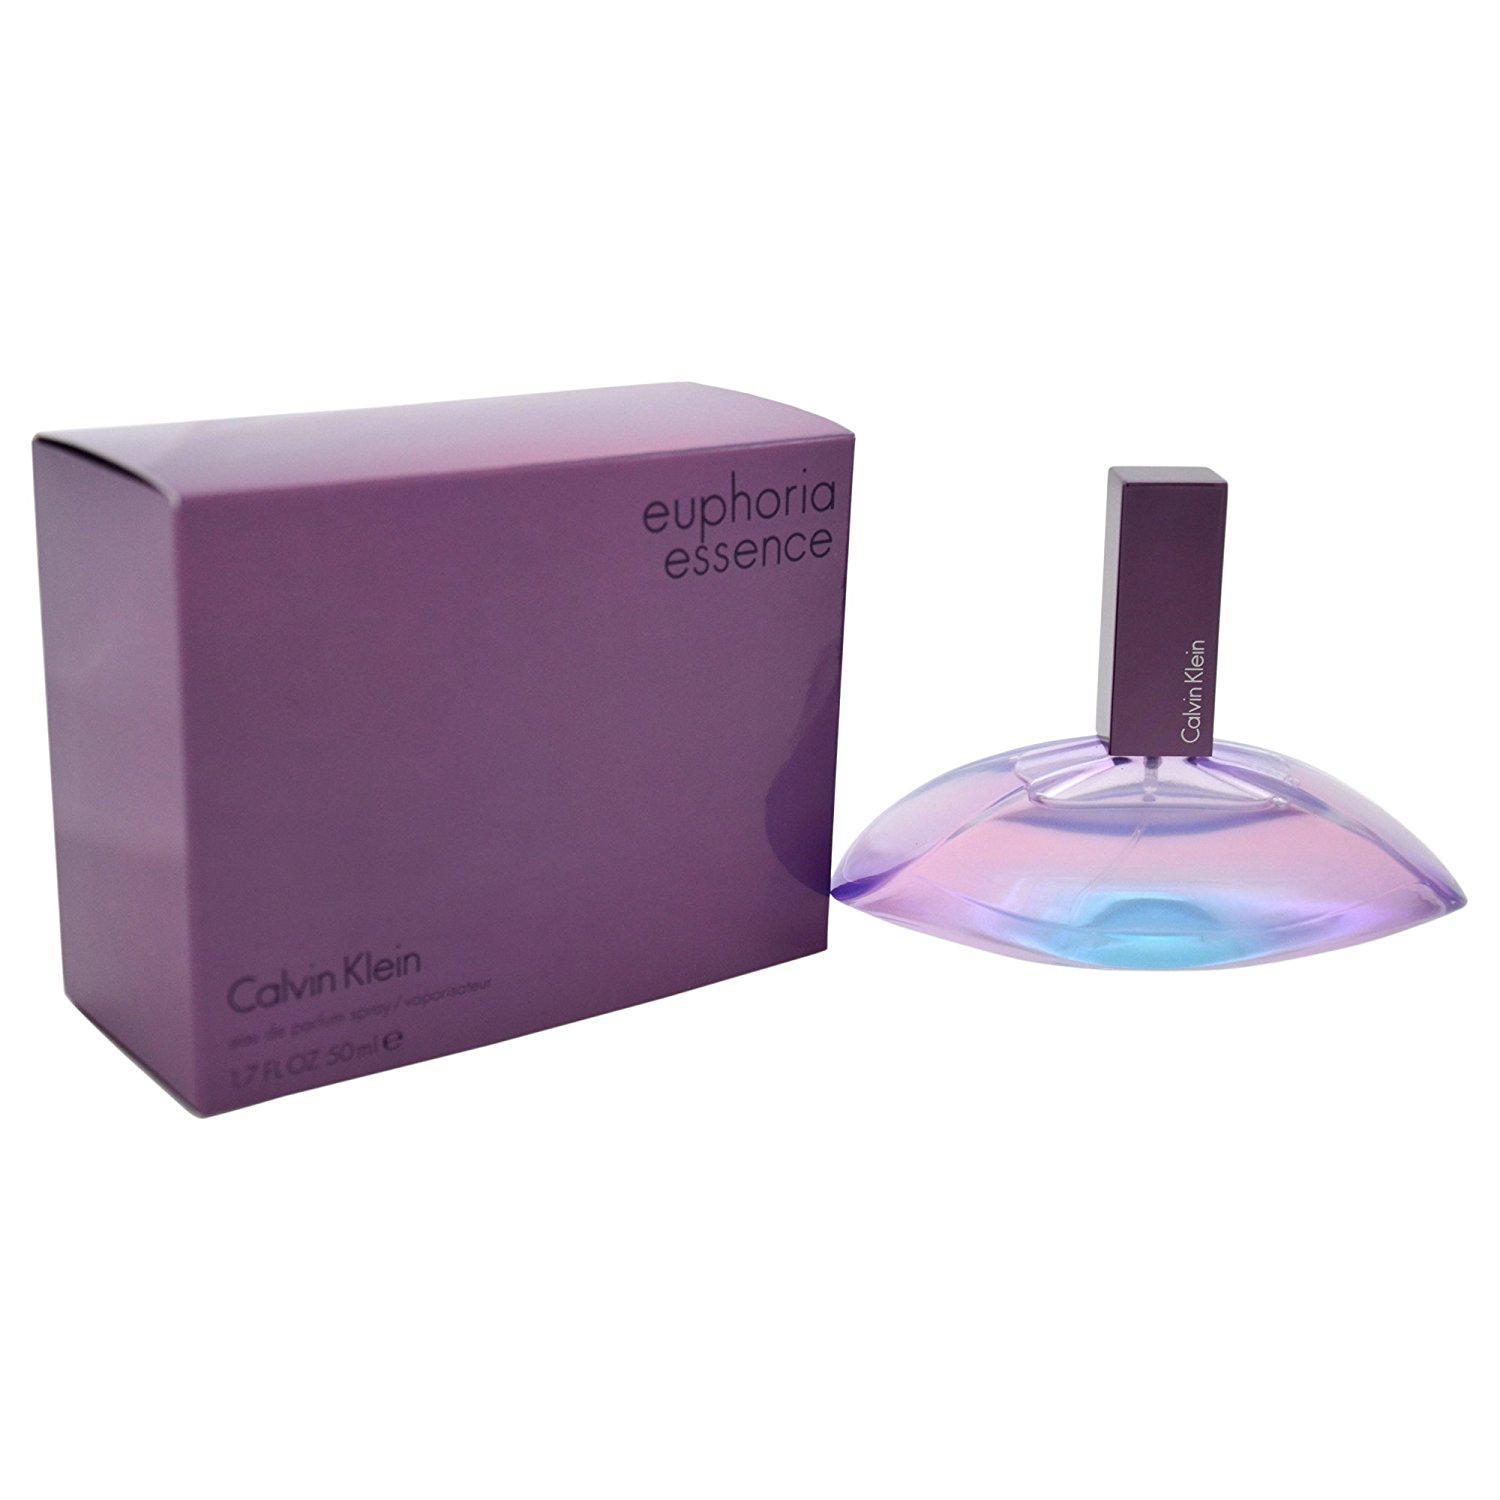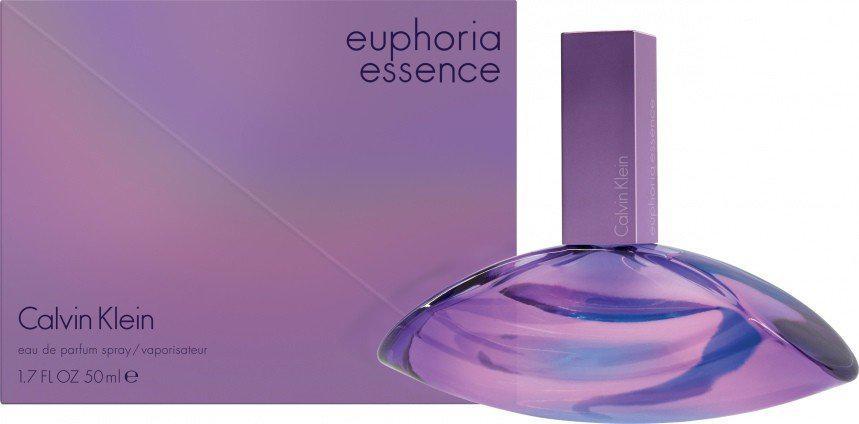The first image is the image on the left, the second image is the image on the right. For the images shown, is this caption "The top of the lid of a purple bottle is visible in the image on the left." true? Answer yes or no. Yes. 